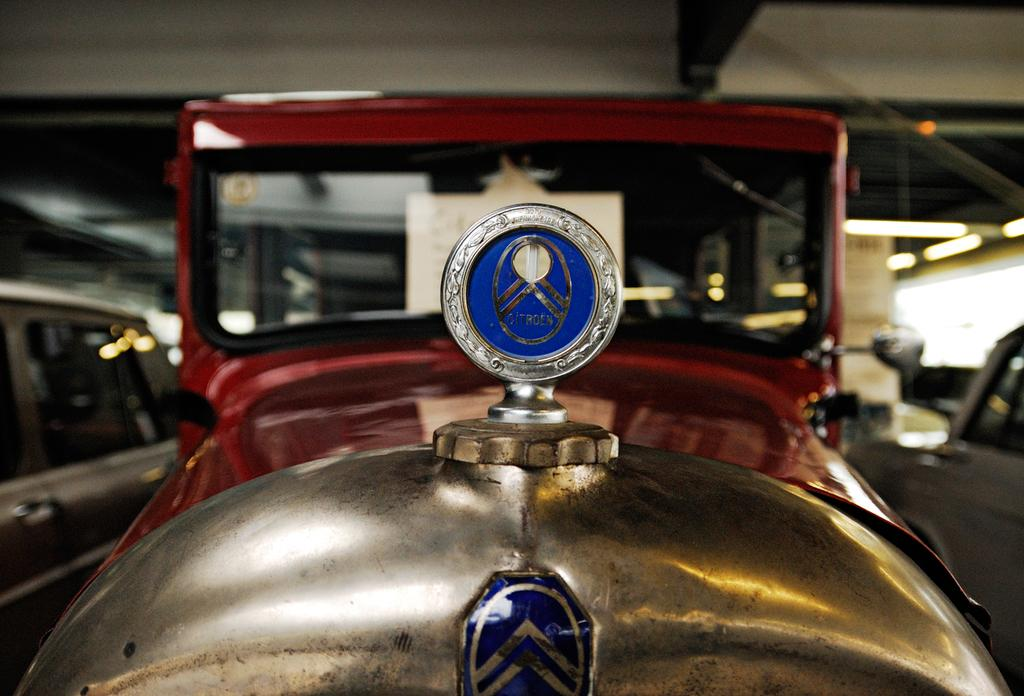What types of objects are present in the image? There are vehicles in the image. Can you describe the color of one of the vehicles? One of the vehicles is red and gold in color. Is there any specific detail about the vehicles that can be identified? There is a blue color logo visible in the image. Are there any corks visible in the image? There are no corks present in the image. Can you identify any crooks or fangs in the image? There are no crooks or fangs present in the image. 